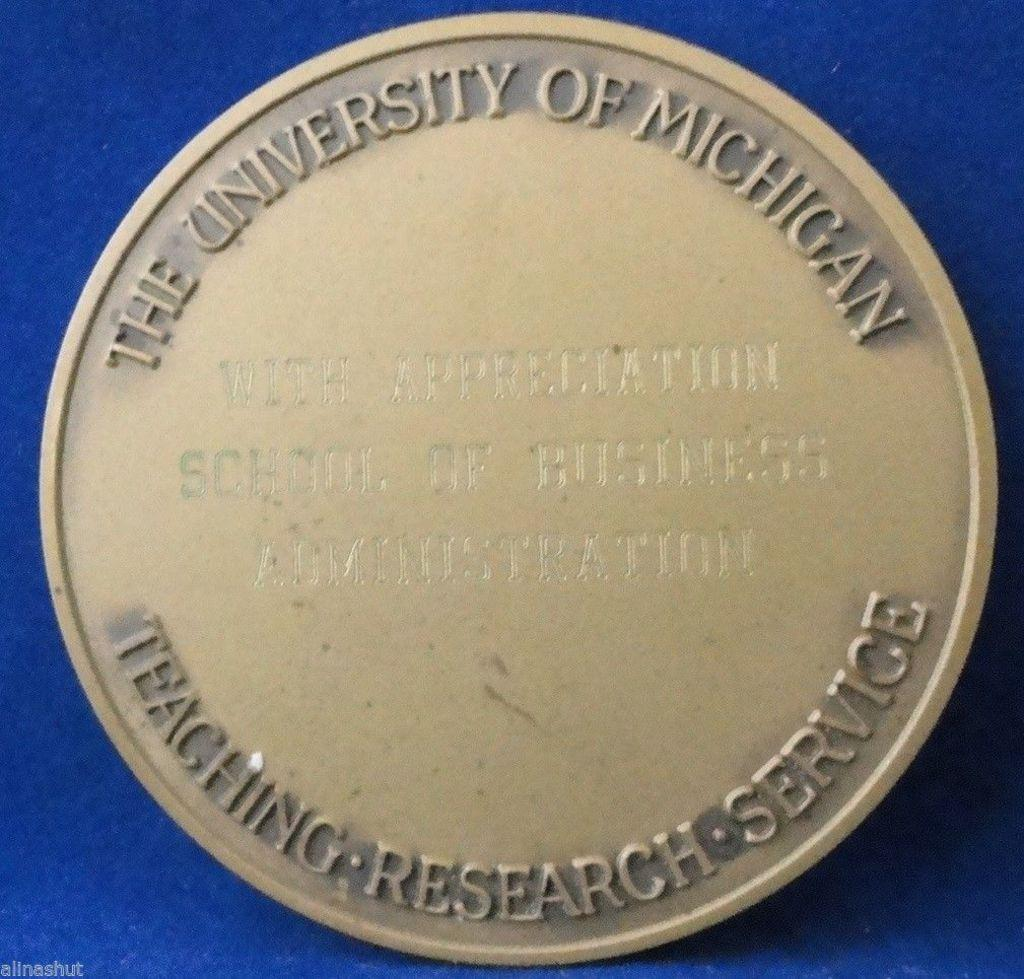<image>
Offer a succinct explanation of the picture presented. A medal from The University of Michigan for Teaching Research Service. 